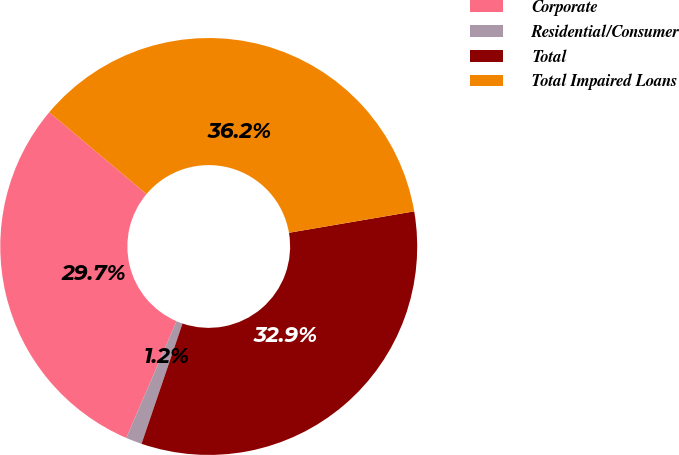Convert chart. <chart><loc_0><loc_0><loc_500><loc_500><pie_chart><fcel>Corporate<fcel>Residential/Consumer<fcel>Total<fcel>Total Impaired Loans<nl><fcel>29.66%<fcel>1.25%<fcel>32.92%<fcel>36.17%<nl></chart> 